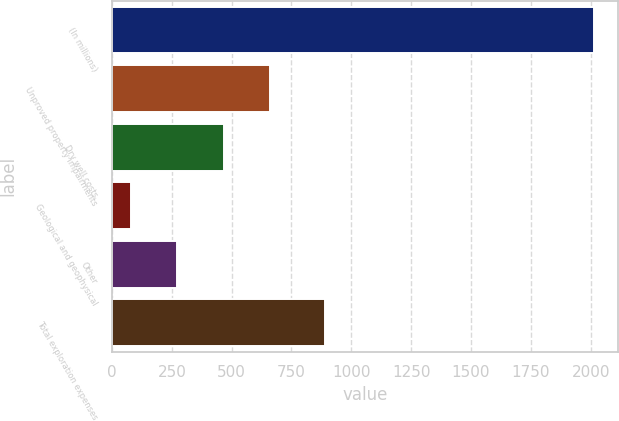Convert chart. <chart><loc_0><loc_0><loc_500><loc_500><bar_chart><fcel>(In millions)<fcel>Unproved property impairments<fcel>Dry well costs<fcel>Geological and geophysical<fcel>Other<fcel>Total exploration expenses<nl><fcel>2013<fcel>659.9<fcel>466.6<fcel>80<fcel>273.3<fcel>891<nl></chart> 